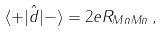Convert formula to latex. <formula><loc_0><loc_0><loc_500><loc_500>\langle + | \hat { d } | - \rangle = 2 e R _ { M n M n } \, ,</formula> 